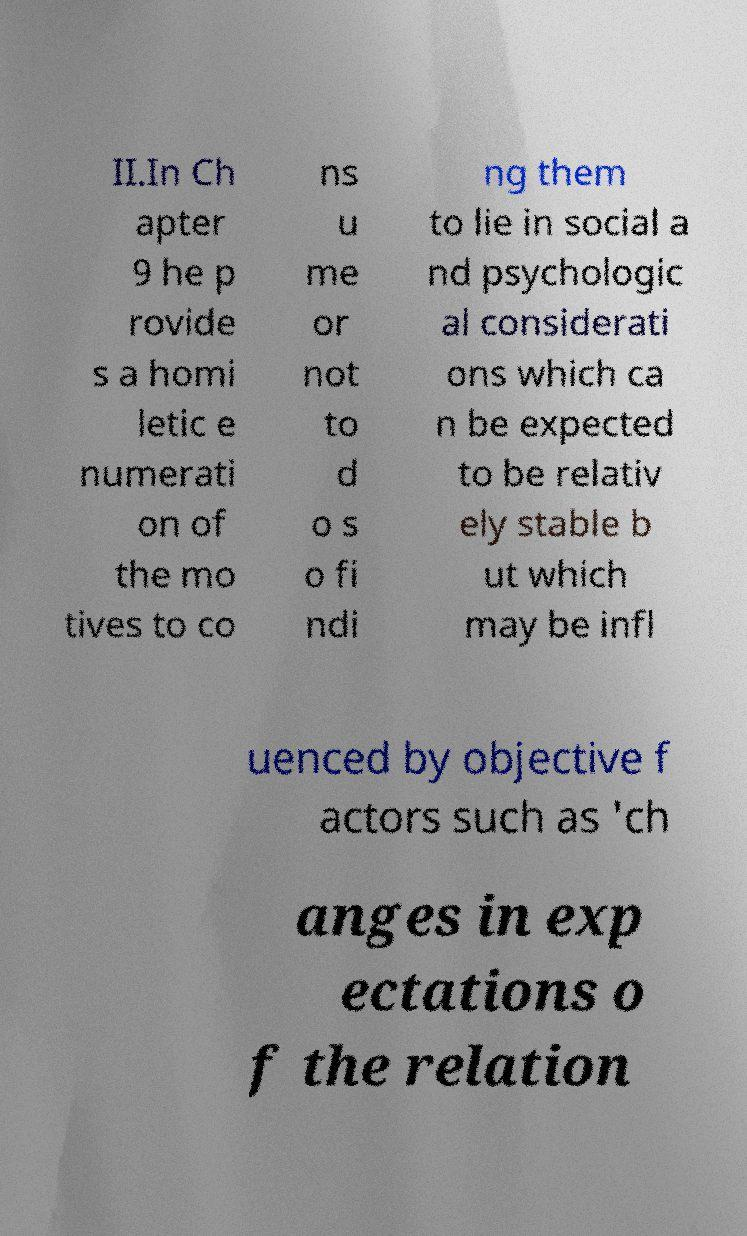What messages or text are displayed in this image? I need them in a readable, typed format. II.In Ch apter 9 he p rovide s a homi letic e numerati on of the mo tives to co ns u me or not to d o s o fi ndi ng them to lie in social a nd psychologic al considerati ons which ca n be expected to be relativ ely stable b ut which may be infl uenced by objective f actors such as 'ch anges in exp ectations o f the relation 